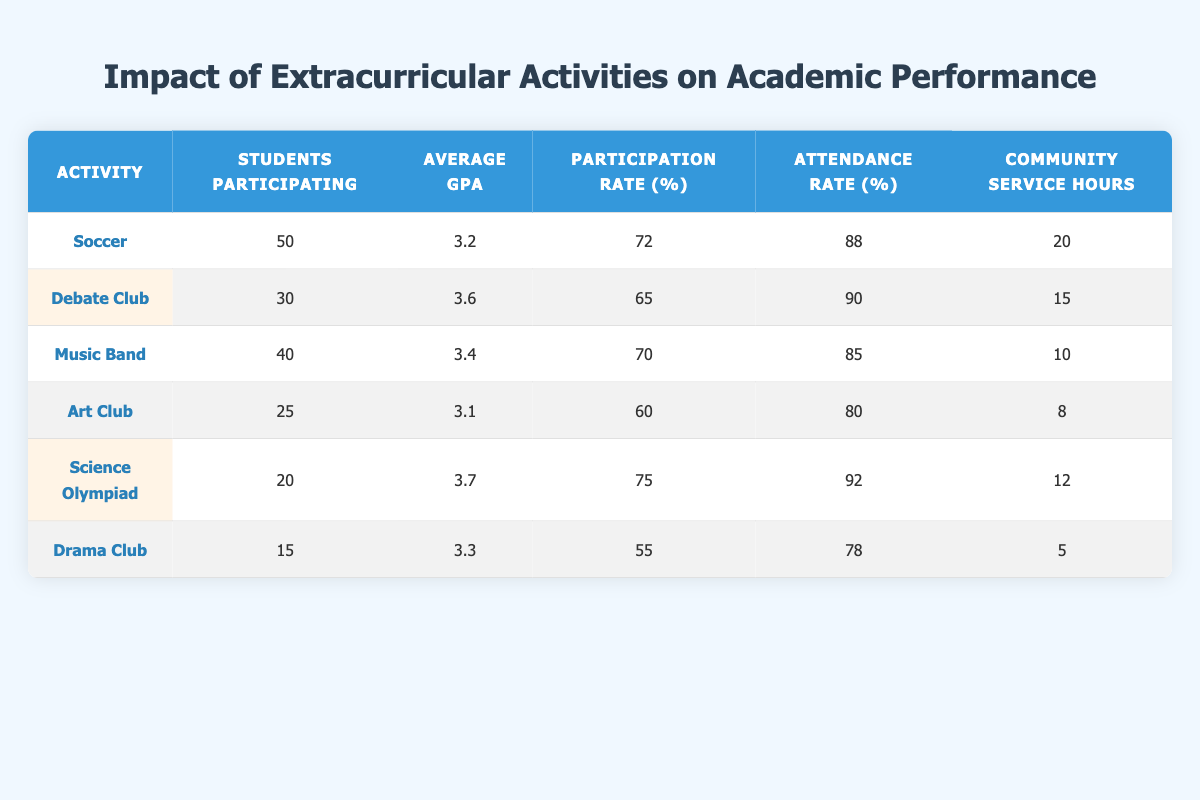What is the average GPA for students participating in the Debate Club? The table shows that the average GPA for Debate Club is 3.6.
Answer: 3.6 How many students participate in the Art Club? The table indicates that there are 25 students participating in the Art Club.
Answer: 25 Which activity has the highest average GPA? By comparing the average GPAs, Science Olympiad has the highest average GPA of 3.7.
Answer: Science Olympiad What is the total number of community service hours for students in the Music Band and Science Olympiad? The community service hours for Music Band are 10 and for Science Olympiad are 12. Adding them gives 10 + 12 = 22 hours.
Answer: 22 Is the participation rate for students in the Drama Club higher than that of the Debate Club? The participation rate for Drama Club is 55%, while for Debate Club, it is 65%. Therefore, Drama Club's participation rate is lower.
Answer: No What is the median attendance rate of all activities listed? The attendance rates in the table are 88, 90, 85, 80, 92, and 78. Arranging them in order: 78, 80, 85, 88, 90, 92, the median (average of the two middle values, 85 and 88) is (85 + 88) / 2 = 86.5.
Answer: 86.5 Which activity has the second-lowest number of students participating? The number of students participating in the activities from lowest to highest is: Drama Club (15), Science Olympiad (20), followed by Art Club (25). Art Club has the second-lowest participation.
Answer: Art Club What is the difference in average GPA between participants of the Soccer and Music Band activities? The average GPA for Soccer is 3.2 and for Music Band is 3.4. The difference is 3.4 - 3.2 = 0.2.
Answer: 0.2 Are more than 30 students participating in the Music Band? The table shows that 40 students are participating in the Music Band, which is greater than 30.
Answer: Yes 